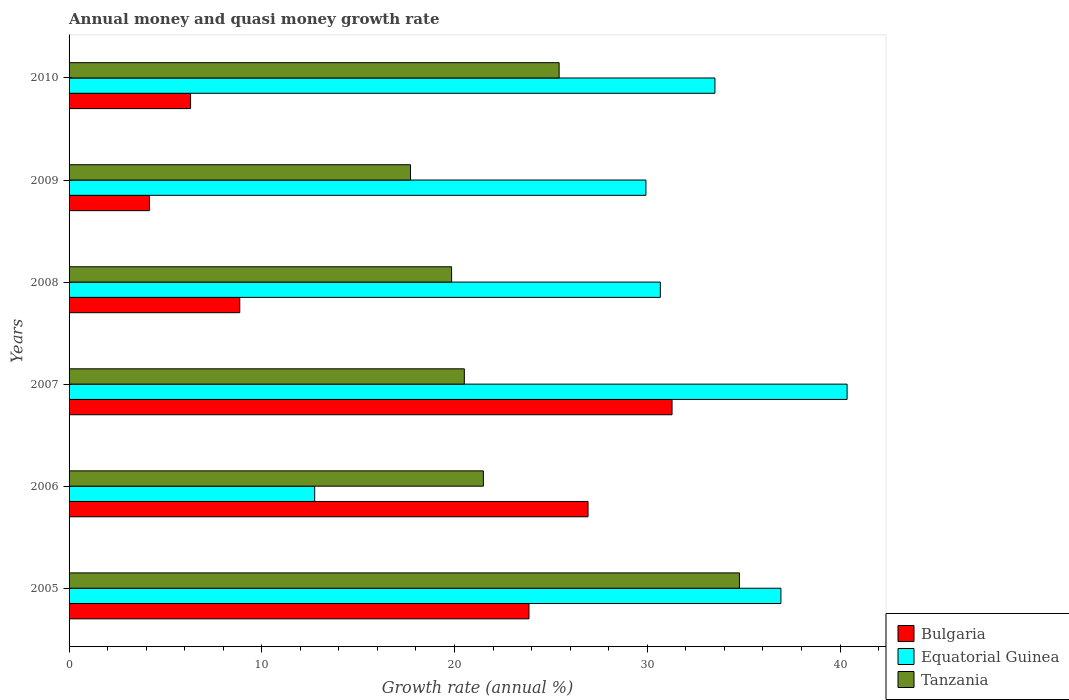How many different coloured bars are there?
Offer a terse response. 3. Are the number of bars per tick equal to the number of legend labels?
Your answer should be very brief. Yes. What is the growth rate in Equatorial Guinea in 2009?
Provide a short and direct response. 29.93. Across all years, what is the maximum growth rate in Bulgaria?
Keep it short and to the point. 31.29. Across all years, what is the minimum growth rate in Bulgaria?
Your answer should be very brief. 4.17. In which year was the growth rate in Bulgaria maximum?
Ensure brevity in your answer.  2007. What is the total growth rate in Tanzania in the graph?
Keep it short and to the point. 139.78. What is the difference between the growth rate in Bulgaria in 2006 and that in 2010?
Make the answer very short. 20.62. What is the difference between the growth rate in Bulgaria in 2006 and the growth rate in Tanzania in 2007?
Make the answer very short. 6.42. What is the average growth rate in Bulgaria per year?
Your response must be concise. 16.9. In the year 2008, what is the difference between the growth rate in Equatorial Guinea and growth rate in Tanzania?
Make the answer very short. 10.83. What is the ratio of the growth rate in Equatorial Guinea in 2006 to that in 2007?
Make the answer very short. 0.32. Is the difference between the growth rate in Equatorial Guinea in 2005 and 2009 greater than the difference between the growth rate in Tanzania in 2005 and 2009?
Give a very brief answer. No. What is the difference between the highest and the second highest growth rate in Equatorial Guinea?
Your response must be concise. 3.43. What is the difference between the highest and the lowest growth rate in Tanzania?
Your answer should be very brief. 17.07. In how many years, is the growth rate in Tanzania greater than the average growth rate in Tanzania taken over all years?
Keep it short and to the point. 2. What does the 2nd bar from the top in 2006 represents?
Offer a terse response. Equatorial Guinea. What does the 2nd bar from the bottom in 2005 represents?
Your answer should be compact. Equatorial Guinea. Are all the bars in the graph horizontal?
Ensure brevity in your answer.  Yes. How many years are there in the graph?
Keep it short and to the point. 6. Are the values on the major ticks of X-axis written in scientific E-notation?
Offer a terse response. No. Does the graph contain grids?
Your answer should be compact. No. How many legend labels are there?
Provide a succinct answer. 3. How are the legend labels stacked?
Your response must be concise. Vertical. What is the title of the graph?
Offer a terse response. Annual money and quasi money growth rate. What is the label or title of the X-axis?
Your response must be concise. Growth rate (annual %). What is the label or title of the Y-axis?
Your answer should be very brief. Years. What is the Growth rate (annual %) of Bulgaria in 2005?
Offer a terse response. 23.86. What is the Growth rate (annual %) in Equatorial Guinea in 2005?
Provide a short and direct response. 36.93. What is the Growth rate (annual %) in Tanzania in 2005?
Provide a short and direct response. 34.78. What is the Growth rate (annual %) in Bulgaria in 2006?
Provide a succinct answer. 26.93. What is the Growth rate (annual %) in Equatorial Guinea in 2006?
Make the answer very short. 12.74. What is the Growth rate (annual %) in Tanzania in 2006?
Ensure brevity in your answer.  21.5. What is the Growth rate (annual %) in Bulgaria in 2007?
Provide a short and direct response. 31.29. What is the Growth rate (annual %) in Equatorial Guinea in 2007?
Give a very brief answer. 40.37. What is the Growth rate (annual %) in Tanzania in 2007?
Ensure brevity in your answer.  20.51. What is the Growth rate (annual %) of Bulgaria in 2008?
Provide a short and direct response. 8.86. What is the Growth rate (annual %) in Equatorial Guinea in 2008?
Keep it short and to the point. 30.68. What is the Growth rate (annual %) of Tanzania in 2008?
Provide a succinct answer. 19.85. What is the Growth rate (annual %) in Bulgaria in 2009?
Give a very brief answer. 4.17. What is the Growth rate (annual %) in Equatorial Guinea in 2009?
Offer a very short reply. 29.93. What is the Growth rate (annual %) of Tanzania in 2009?
Your response must be concise. 17.72. What is the Growth rate (annual %) in Bulgaria in 2010?
Ensure brevity in your answer.  6.3. What is the Growth rate (annual %) in Equatorial Guinea in 2010?
Your response must be concise. 33.51. What is the Growth rate (annual %) of Tanzania in 2010?
Provide a short and direct response. 25.43. Across all years, what is the maximum Growth rate (annual %) in Bulgaria?
Keep it short and to the point. 31.29. Across all years, what is the maximum Growth rate (annual %) in Equatorial Guinea?
Your answer should be compact. 40.37. Across all years, what is the maximum Growth rate (annual %) of Tanzania?
Provide a short and direct response. 34.78. Across all years, what is the minimum Growth rate (annual %) of Bulgaria?
Offer a terse response. 4.17. Across all years, what is the minimum Growth rate (annual %) in Equatorial Guinea?
Keep it short and to the point. 12.74. Across all years, what is the minimum Growth rate (annual %) of Tanzania?
Offer a very short reply. 17.72. What is the total Growth rate (annual %) in Bulgaria in the graph?
Give a very brief answer. 101.41. What is the total Growth rate (annual %) in Equatorial Guinea in the graph?
Offer a terse response. 184.17. What is the total Growth rate (annual %) in Tanzania in the graph?
Your response must be concise. 139.78. What is the difference between the Growth rate (annual %) in Bulgaria in 2005 and that in 2006?
Keep it short and to the point. -3.07. What is the difference between the Growth rate (annual %) of Equatorial Guinea in 2005 and that in 2006?
Your answer should be compact. 24.19. What is the difference between the Growth rate (annual %) in Tanzania in 2005 and that in 2006?
Your answer should be very brief. 13.29. What is the difference between the Growth rate (annual %) of Bulgaria in 2005 and that in 2007?
Your response must be concise. -7.42. What is the difference between the Growth rate (annual %) in Equatorial Guinea in 2005 and that in 2007?
Your answer should be very brief. -3.43. What is the difference between the Growth rate (annual %) in Tanzania in 2005 and that in 2007?
Your answer should be very brief. 14.27. What is the difference between the Growth rate (annual %) of Bulgaria in 2005 and that in 2008?
Your response must be concise. 15.01. What is the difference between the Growth rate (annual %) of Equatorial Guinea in 2005 and that in 2008?
Offer a terse response. 6.25. What is the difference between the Growth rate (annual %) in Tanzania in 2005 and that in 2008?
Provide a succinct answer. 14.93. What is the difference between the Growth rate (annual %) of Bulgaria in 2005 and that in 2009?
Keep it short and to the point. 19.69. What is the difference between the Growth rate (annual %) in Equatorial Guinea in 2005 and that in 2009?
Your answer should be very brief. 7. What is the difference between the Growth rate (annual %) in Tanzania in 2005 and that in 2009?
Your answer should be compact. 17.07. What is the difference between the Growth rate (annual %) in Bulgaria in 2005 and that in 2010?
Give a very brief answer. 17.56. What is the difference between the Growth rate (annual %) in Equatorial Guinea in 2005 and that in 2010?
Provide a short and direct response. 3.42. What is the difference between the Growth rate (annual %) in Tanzania in 2005 and that in 2010?
Give a very brief answer. 9.35. What is the difference between the Growth rate (annual %) in Bulgaria in 2006 and that in 2007?
Your answer should be compact. -4.36. What is the difference between the Growth rate (annual %) of Equatorial Guinea in 2006 and that in 2007?
Provide a short and direct response. -27.62. What is the difference between the Growth rate (annual %) in Tanzania in 2006 and that in 2007?
Ensure brevity in your answer.  0.99. What is the difference between the Growth rate (annual %) of Bulgaria in 2006 and that in 2008?
Your answer should be very brief. 18.07. What is the difference between the Growth rate (annual %) in Equatorial Guinea in 2006 and that in 2008?
Make the answer very short. -17.94. What is the difference between the Growth rate (annual %) of Tanzania in 2006 and that in 2008?
Make the answer very short. 1.65. What is the difference between the Growth rate (annual %) in Bulgaria in 2006 and that in 2009?
Make the answer very short. 22.76. What is the difference between the Growth rate (annual %) of Equatorial Guinea in 2006 and that in 2009?
Offer a terse response. -17.19. What is the difference between the Growth rate (annual %) in Tanzania in 2006 and that in 2009?
Give a very brief answer. 3.78. What is the difference between the Growth rate (annual %) in Bulgaria in 2006 and that in 2010?
Provide a succinct answer. 20.62. What is the difference between the Growth rate (annual %) of Equatorial Guinea in 2006 and that in 2010?
Offer a terse response. -20.77. What is the difference between the Growth rate (annual %) in Tanzania in 2006 and that in 2010?
Provide a short and direct response. -3.93. What is the difference between the Growth rate (annual %) of Bulgaria in 2007 and that in 2008?
Your response must be concise. 22.43. What is the difference between the Growth rate (annual %) of Equatorial Guinea in 2007 and that in 2008?
Keep it short and to the point. 9.69. What is the difference between the Growth rate (annual %) of Tanzania in 2007 and that in 2008?
Your response must be concise. 0.66. What is the difference between the Growth rate (annual %) in Bulgaria in 2007 and that in 2009?
Offer a very short reply. 27.11. What is the difference between the Growth rate (annual %) in Equatorial Guinea in 2007 and that in 2009?
Keep it short and to the point. 10.44. What is the difference between the Growth rate (annual %) in Tanzania in 2007 and that in 2009?
Provide a succinct answer. 2.79. What is the difference between the Growth rate (annual %) of Bulgaria in 2007 and that in 2010?
Provide a succinct answer. 24.98. What is the difference between the Growth rate (annual %) of Equatorial Guinea in 2007 and that in 2010?
Your answer should be very brief. 6.86. What is the difference between the Growth rate (annual %) of Tanzania in 2007 and that in 2010?
Ensure brevity in your answer.  -4.92. What is the difference between the Growth rate (annual %) of Bulgaria in 2008 and that in 2009?
Give a very brief answer. 4.68. What is the difference between the Growth rate (annual %) of Equatorial Guinea in 2008 and that in 2009?
Offer a terse response. 0.75. What is the difference between the Growth rate (annual %) in Tanzania in 2008 and that in 2009?
Offer a terse response. 2.13. What is the difference between the Growth rate (annual %) of Bulgaria in 2008 and that in 2010?
Your answer should be compact. 2.55. What is the difference between the Growth rate (annual %) of Equatorial Guinea in 2008 and that in 2010?
Provide a succinct answer. -2.83. What is the difference between the Growth rate (annual %) of Tanzania in 2008 and that in 2010?
Keep it short and to the point. -5.58. What is the difference between the Growth rate (annual %) in Bulgaria in 2009 and that in 2010?
Provide a short and direct response. -2.13. What is the difference between the Growth rate (annual %) in Equatorial Guinea in 2009 and that in 2010?
Provide a short and direct response. -3.58. What is the difference between the Growth rate (annual %) in Tanzania in 2009 and that in 2010?
Provide a succinct answer. -7.71. What is the difference between the Growth rate (annual %) in Bulgaria in 2005 and the Growth rate (annual %) in Equatorial Guinea in 2006?
Your answer should be compact. 11.12. What is the difference between the Growth rate (annual %) of Bulgaria in 2005 and the Growth rate (annual %) of Tanzania in 2006?
Your answer should be compact. 2.37. What is the difference between the Growth rate (annual %) of Equatorial Guinea in 2005 and the Growth rate (annual %) of Tanzania in 2006?
Provide a succinct answer. 15.44. What is the difference between the Growth rate (annual %) in Bulgaria in 2005 and the Growth rate (annual %) in Equatorial Guinea in 2007?
Keep it short and to the point. -16.51. What is the difference between the Growth rate (annual %) of Bulgaria in 2005 and the Growth rate (annual %) of Tanzania in 2007?
Your response must be concise. 3.35. What is the difference between the Growth rate (annual %) of Equatorial Guinea in 2005 and the Growth rate (annual %) of Tanzania in 2007?
Your answer should be compact. 16.43. What is the difference between the Growth rate (annual %) in Bulgaria in 2005 and the Growth rate (annual %) in Equatorial Guinea in 2008?
Keep it short and to the point. -6.82. What is the difference between the Growth rate (annual %) of Bulgaria in 2005 and the Growth rate (annual %) of Tanzania in 2008?
Keep it short and to the point. 4.01. What is the difference between the Growth rate (annual %) of Equatorial Guinea in 2005 and the Growth rate (annual %) of Tanzania in 2008?
Offer a very short reply. 17.09. What is the difference between the Growth rate (annual %) of Bulgaria in 2005 and the Growth rate (annual %) of Equatorial Guinea in 2009?
Your answer should be compact. -6.07. What is the difference between the Growth rate (annual %) of Bulgaria in 2005 and the Growth rate (annual %) of Tanzania in 2009?
Provide a succinct answer. 6.15. What is the difference between the Growth rate (annual %) in Equatorial Guinea in 2005 and the Growth rate (annual %) in Tanzania in 2009?
Provide a short and direct response. 19.22. What is the difference between the Growth rate (annual %) of Bulgaria in 2005 and the Growth rate (annual %) of Equatorial Guinea in 2010?
Give a very brief answer. -9.65. What is the difference between the Growth rate (annual %) of Bulgaria in 2005 and the Growth rate (annual %) of Tanzania in 2010?
Your answer should be compact. -1.56. What is the difference between the Growth rate (annual %) of Equatorial Guinea in 2005 and the Growth rate (annual %) of Tanzania in 2010?
Your response must be concise. 11.51. What is the difference between the Growth rate (annual %) in Bulgaria in 2006 and the Growth rate (annual %) in Equatorial Guinea in 2007?
Offer a terse response. -13.44. What is the difference between the Growth rate (annual %) in Bulgaria in 2006 and the Growth rate (annual %) in Tanzania in 2007?
Your answer should be compact. 6.42. What is the difference between the Growth rate (annual %) of Equatorial Guinea in 2006 and the Growth rate (annual %) of Tanzania in 2007?
Your answer should be very brief. -7.76. What is the difference between the Growth rate (annual %) in Bulgaria in 2006 and the Growth rate (annual %) in Equatorial Guinea in 2008?
Keep it short and to the point. -3.75. What is the difference between the Growth rate (annual %) in Bulgaria in 2006 and the Growth rate (annual %) in Tanzania in 2008?
Ensure brevity in your answer.  7.08. What is the difference between the Growth rate (annual %) of Equatorial Guinea in 2006 and the Growth rate (annual %) of Tanzania in 2008?
Give a very brief answer. -7.1. What is the difference between the Growth rate (annual %) in Bulgaria in 2006 and the Growth rate (annual %) in Equatorial Guinea in 2009?
Make the answer very short. -3. What is the difference between the Growth rate (annual %) of Bulgaria in 2006 and the Growth rate (annual %) of Tanzania in 2009?
Your answer should be very brief. 9.21. What is the difference between the Growth rate (annual %) in Equatorial Guinea in 2006 and the Growth rate (annual %) in Tanzania in 2009?
Offer a very short reply. -4.97. What is the difference between the Growth rate (annual %) in Bulgaria in 2006 and the Growth rate (annual %) in Equatorial Guinea in 2010?
Your response must be concise. -6.58. What is the difference between the Growth rate (annual %) of Bulgaria in 2006 and the Growth rate (annual %) of Tanzania in 2010?
Give a very brief answer. 1.5. What is the difference between the Growth rate (annual %) in Equatorial Guinea in 2006 and the Growth rate (annual %) in Tanzania in 2010?
Offer a terse response. -12.68. What is the difference between the Growth rate (annual %) in Bulgaria in 2007 and the Growth rate (annual %) in Equatorial Guinea in 2008?
Ensure brevity in your answer.  0.61. What is the difference between the Growth rate (annual %) in Bulgaria in 2007 and the Growth rate (annual %) in Tanzania in 2008?
Your answer should be very brief. 11.44. What is the difference between the Growth rate (annual %) in Equatorial Guinea in 2007 and the Growth rate (annual %) in Tanzania in 2008?
Ensure brevity in your answer.  20.52. What is the difference between the Growth rate (annual %) in Bulgaria in 2007 and the Growth rate (annual %) in Equatorial Guinea in 2009?
Give a very brief answer. 1.36. What is the difference between the Growth rate (annual %) of Bulgaria in 2007 and the Growth rate (annual %) of Tanzania in 2009?
Ensure brevity in your answer.  13.57. What is the difference between the Growth rate (annual %) in Equatorial Guinea in 2007 and the Growth rate (annual %) in Tanzania in 2009?
Provide a succinct answer. 22.65. What is the difference between the Growth rate (annual %) in Bulgaria in 2007 and the Growth rate (annual %) in Equatorial Guinea in 2010?
Keep it short and to the point. -2.23. What is the difference between the Growth rate (annual %) of Bulgaria in 2007 and the Growth rate (annual %) of Tanzania in 2010?
Make the answer very short. 5.86. What is the difference between the Growth rate (annual %) in Equatorial Guinea in 2007 and the Growth rate (annual %) in Tanzania in 2010?
Keep it short and to the point. 14.94. What is the difference between the Growth rate (annual %) of Bulgaria in 2008 and the Growth rate (annual %) of Equatorial Guinea in 2009?
Provide a short and direct response. -21.07. What is the difference between the Growth rate (annual %) of Bulgaria in 2008 and the Growth rate (annual %) of Tanzania in 2009?
Give a very brief answer. -8.86. What is the difference between the Growth rate (annual %) of Equatorial Guinea in 2008 and the Growth rate (annual %) of Tanzania in 2009?
Give a very brief answer. 12.96. What is the difference between the Growth rate (annual %) of Bulgaria in 2008 and the Growth rate (annual %) of Equatorial Guinea in 2010?
Your response must be concise. -24.65. What is the difference between the Growth rate (annual %) of Bulgaria in 2008 and the Growth rate (annual %) of Tanzania in 2010?
Make the answer very short. -16.57. What is the difference between the Growth rate (annual %) of Equatorial Guinea in 2008 and the Growth rate (annual %) of Tanzania in 2010?
Ensure brevity in your answer.  5.25. What is the difference between the Growth rate (annual %) in Bulgaria in 2009 and the Growth rate (annual %) in Equatorial Guinea in 2010?
Provide a short and direct response. -29.34. What is the difference between the Growth rate (annual %) of Bulgaria in 2009 and the Growth rate (annual %) of Tanzania in 2010?
Your answer should be very brief. -21.25. What is the difference between the Growth rate (annual %) in Equatorial Guinea in 2009 and the Growth rate (annual %) in Tanzania in 2010?
Provide a short and direct response. 4.5. What is the average Growth rate (annual %) in Bulgaria per year?
Offer a terse response. 16.9. What is the average Growth rate (annual %) of Equatorial Guinea per year?
Your answer should be very brief. 30.69. What is the average Growth rate (annual %) of Tanzania per year?
Offer a very short reply. 23.3. In the year 2005, what is the difference between the Growth rate (annual %) of Bulgaria and Growth rate (annual %) of Equatorial Guinea?
Your answer should be very brief. -13.07. In the year 2005, what is the difference between the Growth rate (annual %) in Bulgaria and Growth rate (annual %) in Tanzania?
Provide a succinct answer. -10.92. In the year 2005, what is the difference between the Growth rate (annual %) of Equatorial Guinea and Growth rate (annual %) of Tanzania?
Keep it short and to the point. 2.15. In the year 2006, what is the difference between the Growth rate (annual %) of Bulgaria and Growth rate (annual %) of Equatorial Guinea?
Offer a very short reply. 14.18. In the year 2006, what is the difference between the Growth rate (annual %) in Bulgaria and Growth rate (annual %) in Tanzania?
Provide a short and direct response. 5.43. In the year 2006, what is the difference between the Growth rate (annual %) in Equatorial Guinea and Growth rate (annual %) in Tanzania?
Give a very brief answer. -8.75. In the year 2007, what is the difference between the Growth rate (annual %) in Bulgaria and Growth rate (annual %) in Equatorial Guinea?
Ensure brevity in your answer.  -9.08. In the year 2007, what is the difference between the Growth rate (annual %) of Bulgaria and Growth rate (annual %) of Tanzania?
Your response must be concise. 10.78. In the year 2007, what is the difference between the Growth rate (annual %) in Equatorial Guinea and Growth rate (annual %) in Tanzania?
Your response must be concise. 19.86. In the year 2008, what is the difference between the Growth rate (annual %) in Bulgaria and Growth rate (annual %) in Equatorial Guinea?
Keep it short and to the point. -21.82. In the year 2008, what is the difference between the Growth rate (annual %) of Bulgaria and Growth rate (annual %) of Tanzania?
Offer a very short reply. -10.99. In the year 2008, what is the difference between the Growth rate (annual %) in Equatorial Guinea and Growth rate (annual %) in Tanzania?
Give a very brief answer. 10.83. In the year 2009, what is the difference between the Growth rate (annual %) in Bulgaria and Growth rate (annual %) in Equatorial Guinea?
Your answer should be very brief. -25.76. In the year 2009, what is the difference between the Growth rate (annual %) in Bulgaria and Growth rate (annual %) in Tanzania?
Offer a very short reply. -13.54. In the year 2009, what is the difference between the Growth rate (annual %) in Equatorial Guinea and Growth rate (annual %) in Tanzania?
Provide a short and direct response. 12.21. In the year 2010, what is the difference between the Growth rate (annual %) in Bulgaria and Growth rate (annual %) in Equatorial Guinea?
Offer a very short reply. -27.21. In the year 2010, what is the difference between the Growth rate (annual %) in Bulgaria and Growth rate (annual %) in Tanzania?
Provide a succinct answer. -19.12. In the year 2010, what is the difference between the Growth rate (annual %) in Equatorial Guinea and Growth rate (annual %) in Tanzania?
Provide a short and direct response. 8.08. What is the ratio of the Growth rate (annual %) of Bulgaria in 2005 to that in 2006?
Your answer should be very brief. 0.89. What is the ratio of the Growth rate (annual %) of Equatorial Guinea in 2005 to that in 2006?
Keep it short and to the point. 2.9. What is the ratio of the Growth rate (annual %) of Tanzania in 2005 to that in 2006?
Provide a short and direct response. 1.62. What is the ratio of the Growth rate (annual %) of Bulgaria in 2005 to that in 2007?
Keep it short and to the point. 0.76. What is the ratio of the Growth rate (annual %) of Equatorial Guinea in 2005 to that in 2007?
Give a very brief answer. 0.91. What is the ratio of the Growth rate (annual %) in Tanzania in 2005 to that in 2007?
Your response must be concise. 1.7. What is the ratio of the Growth rate (annual %) in Bulgaria in 2005 to that in 2008?
Your answer should be compact. 2.69. What is the ratio of the Growth rate (annual %) of Equatorial Guinea in 2005 to that in 2008?
Provide a succinct answer. 1.2. What is the ratio of the Growth rate (annual %) in Tanzania in 2005 to that in 2008?
Your response must be concise. 1.75. What is the ratio of the Growth rate (annual %) in Bulgaria in 2005 to that in 2009?
Your answer should be very brief. 5.72. What is the ratio of the Growth rate (annual %) of Equatorial Guinea in 2005 to that in 2009?
Your answer should be compact. 1.23. What is the ratio of the Growth rate (annual %) of Tanzania in 2005 to that in 2009?
Your response must be concise. 1.96. What is the ratio of the Growth rate (annual %) in Bulgaria in 2005 to that in 2010?
Keep it short and to the point. 3.78. What is the ratio of the Growth rate (annual %) of Equatorial Guinea in 2005 to that in 2010?
Provide a succinct answer. 1.1. What is the ratio of the Growth rate (annual %) in Tanzania in 2005 to that in 2010?
Provide a succinct answer. 1.37. What is the ratio of the Growth rate (annual %) of Bulgaria in 2006 to that in 2007?
Offer a very short reply. 0.86. What is the ratio of the Growth rate (annual %) of Equatorial Guinea in 2006 to that in 2007?
Your answer should be very brief. 0.32. What is the ratio of the Growth rate (annual %) of Tanzania in 2006 to that in 2007?
Ensure brevity in your answer.  1.05. What is the ratio of the Growth rate (annual %) in Bulgaria in 2006 to that in 2008?
Make the answer very short. 3.04. What is the ratio of the Growth rate (annual %) in Equatorial Guinea in 2006 to that in 2008?
Give a very brief answer. 0.42. What is the ratio of the Growth rate (annual %) in Tanzania in 2006 to that in 2008?
Provide a succinct answer. 1.08. What is the ratio of the Growth rate (annual %) in Bulgaria in 2006 to that in 2009?
Provide a short and direct response. 6.45. What is the ratio of the Growth rate (annual %) in Equatorial Guinea in 2006 to that in 2009?
Ensure brevity in your answer.  0.43. What is the ratio of the Growth rate (annual %) in Tanzania in 2006 to that in 2009?
Ensure brevity in your answer.  1.21. What is the ratio of the Growth rate (annual %) of Bulgaria in 2006 to that in 2010?
Your answer should be compact. 4.27. What is the ratio of the Growth rate (annual %) of Equatorial Guinea in 2006 to that in 2010?
Provide a short and direct response. 0.38. What is the ratio of the Growth rate (annual %) of Tanzania in 2006 to that in 2010?
Your response must be concise. 0.85. What is the ratio of the Growth rate (annual %) of Bulgaria in 2007 to that in 2008?
Your response must be concise. 3.53. What is the ratio of the Growth rate (annual %) in Equatorial Guinea in 2007 to that in 2008?
Make the answer very short. 1.32. What is the ratio of the Growth rate (annual %) of Bulgaria in 2007 to that in 2009?
Provide a short and direct response. 7.5. What is the ratio of the Growth rate (annual %) in Equatorial Guinea in 2007 to that in 2009?
Offer a very short reply. 1.35. What is the ratio of the Growth rate (annual %) in Tanzania in 2007 to that in 2009?
Your response must be concise. 1.16. What is the ratio of the Growth rate (annual %) of Bulgaria in 2007 to that in 2010?
Your answer should be compact. 4.96. What is the ratio of the Growth rate (annual %) in Equatorial Guinea in 2007 to that in 2010?
Keep it short and to the point. 1.2. What is the ratio of the Growth rate (annual %) in Tanzania in 2007 to that in 2010?
Offer a terse response. 0.81. What is the ratio of the Growth rate (annual %) in Bulgaria in 2008 to that in 2009?
Provide a short and direct response. 2.12. What is the ratio of the Growth rate (annual %) in Tanzania in 2008 to that in 2009?
Your response must be concise. 1.12. What is the ratio of the Growth rate (annual %) in Bulgaria in 2008 to that in 2010?
Make the answer very short. 1.4. What is the ratio of the Growth rate (annual %) in Equatorial Guinea in 2008 to that in 2010?
Your answer should be very brief. 0.92. What is the ratio of the Growth rate (annual %) of Tanzania in 2008 to that in 2010?
Ensure brevity in your answer.  0.78. What is the ratio of the Growth rate (annual %) in Bulgaria in 2009 to that in 2010?
Your answer should be very brief. 0.66. What is the ratio of the Growth rate (annual %) of Equatorial Guinea in 2009 to that in 2010?
Your answer should be very brief. 0.89. What is the ratio of the Growth rate (annual %) in Tanzania in 2009 to that in 2010?
Your answer should be very brief. 0.7. What is the difference between the highest and the second highest Growth rate (annual %) of Bulgaria?
Make the answer very short. 4.36. What is the difference between the highest and the second highest Growth rate (annual %) of Equatorial Guinea?
Offer a very short reply. 3.43. What is the difference between the highest and the second highest Growth rate (annual %) of Tanzania?
Your response must be concise. 9.35. What is the difference between the highest and the lowest Growth rate (annual %) of Bulgaria?
Provide a succinct answer. 27.11. What is the difference between the highest and the lowest Growth rate (annual %) of Equatorial Guinea?
Offer a terse response. 27.62. What is the difference between the highest and the lowest Growth rate (annual %) of Tanzania?
Keep it short and to the point. 17.07. 